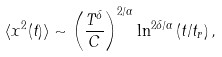Convert formula to latex. <formula><loc_0><loc_0><loc_500><loc_500>\langle x ^ { 2 } ( t ) \rangle \sim { \left ( \frac { T ^ { \delta } } { C } \right ) } ^ { { 2 } / { \alpha } } \ln ^ { { 2 \delta } / { \alpha } } \left ( { t } / { t _ { r } } \right ) ,</formula> 